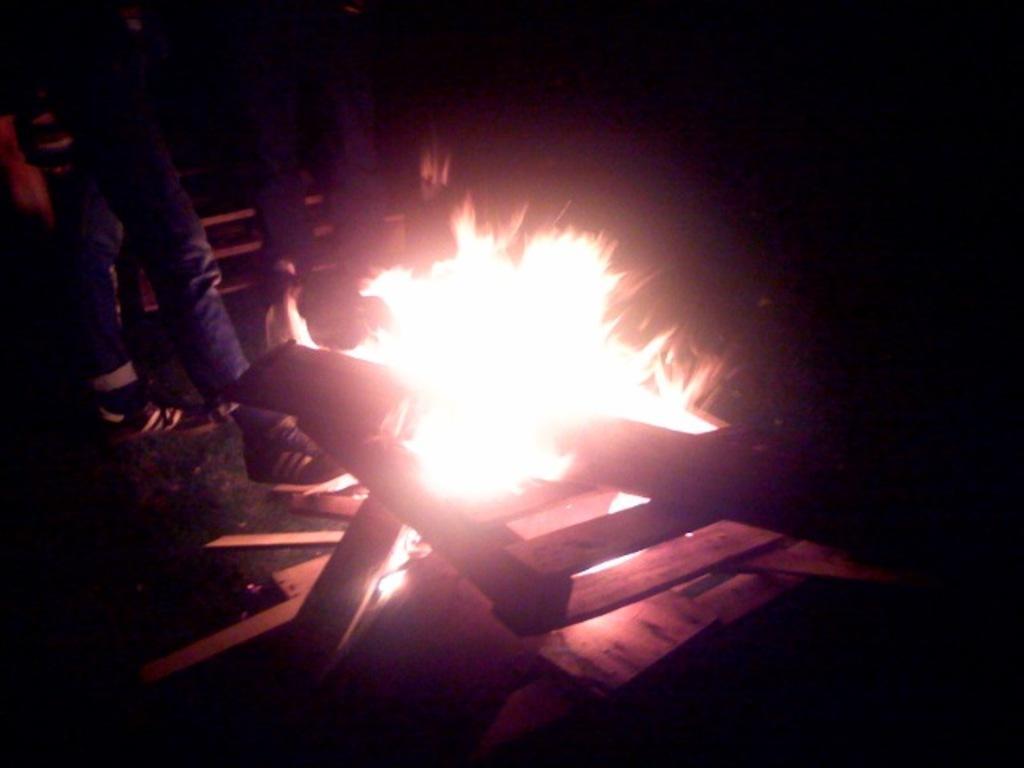Can you describe this image briefly? In this image, we can see fire and some wood. We can also see the legs of a few people. We can also see the ground. 